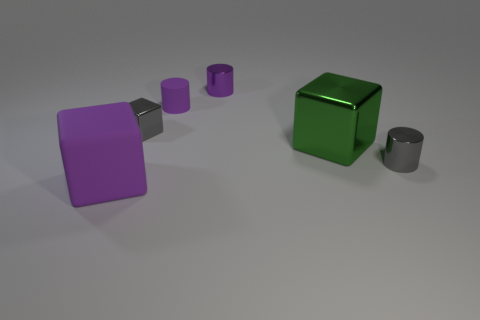Subtract 1 cylinders. How many cylinders are left? 2 Add 4 yellow shiny things. How many objects exist? 10 Add 6 gray things. How many gray things are left? 8 Add 5 yellow matte objects. How many yellow matte objects exist? 5 Subtract 1 gray blocks. How many objects are left? 5 Subtract all small shiny cylinders. Subtract all large gray rubber objects. How many objects are left? 4 